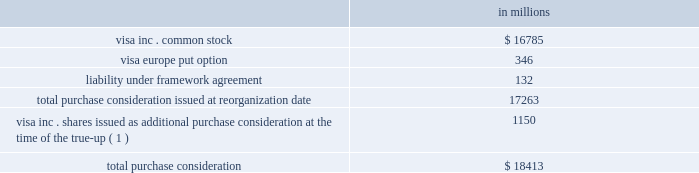Visa inc .
Notes to consolidated financial statements 2014 ( continued ) september 30 , 2008 ( in millions , except as noted ) purchase consideration total purchase consideration of approximately $ 17.3 billion was exchanged in october 2007 for the acquired interests .
The consideration was comprised of the following: .
( 1 ) see description of the true-up of purchase consideration below .
See note 4 2014visa europe for more information related to the visa europe put option and the liability under framework agreement .
Visa inc .
Common stock issued in exchange for the acquired regions the value of the purchase consideration conveyed to each of the member groups of the acquired regions was determined by valuing the underlying businesses contributed by each , after giving effect to negotiated adjustments .
The value of the purchase consideration , consisting of all outstanding shares of class canada , class ap , class lac and class cemea common stock , was measured at june 15 , 2007 ( the 201cmeasurement date 201d ) , the date on which all parties entered into the global restructuring agreement , and was determined to have a fair value of approximately $ 12.6 billion .
The company primarily relied upon the analysis of comparable companies with similar industry , business model and financial profiles .
This analysis considered a range of metrics including the forward multiples of revenue ; earnings before interest , depreciation and amortization ; and net income of comparable companies .
Ultimately , the company determined that the forward net income multiple was the most appropriate measure to value the acquired regions and reflect anticipated changes in the company 2019s financial profile prospectively .
This multiple was applied to the corresponding forward net income of the acquired regions to calculate their value .
The most comparable company identified was mastercard inc .
Therefore , the most significant input into this analysis was mastercard 2019s forward net income multiple of 27 times net income at the measurement date .
The company additionally performed discounted cash flow analyses for each region .
These analyses considered the company 2019s forecast by region and incorporated market participant assumptions for growth and profitability .
The cash flows were discounted using rates ranging from 12-16% ( 12-16 % ) , reflecting returns for investments times earnings before interest , tax , depreciation and amortization ( 201cebitda 201d ) to ascribe value to periods beyond the company 2019s forecast , consistent with recent payment processing , financial exchange and credit card precedent transactions. .
What portion of the total purchase consideration was issued at the time of the true-up? 
Computations: (1150 / 18413)
Answer: 0.06246. 